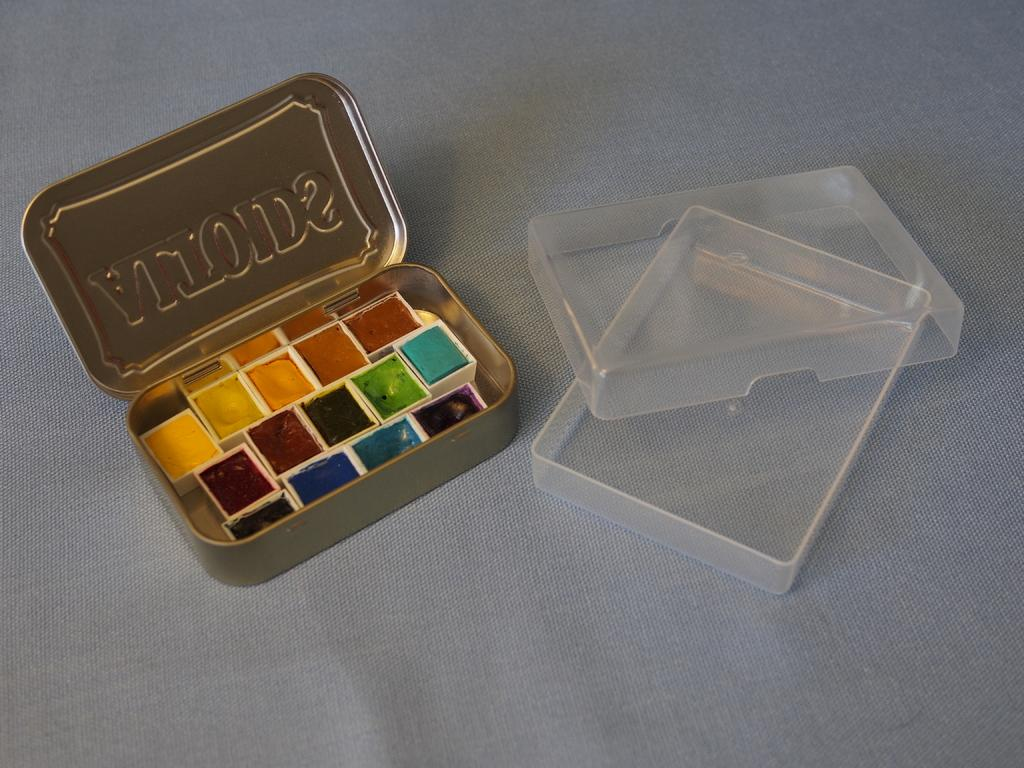<image>
Render a clear and concise summary of the photo. In this make-up case the letters AIT start upside down. 